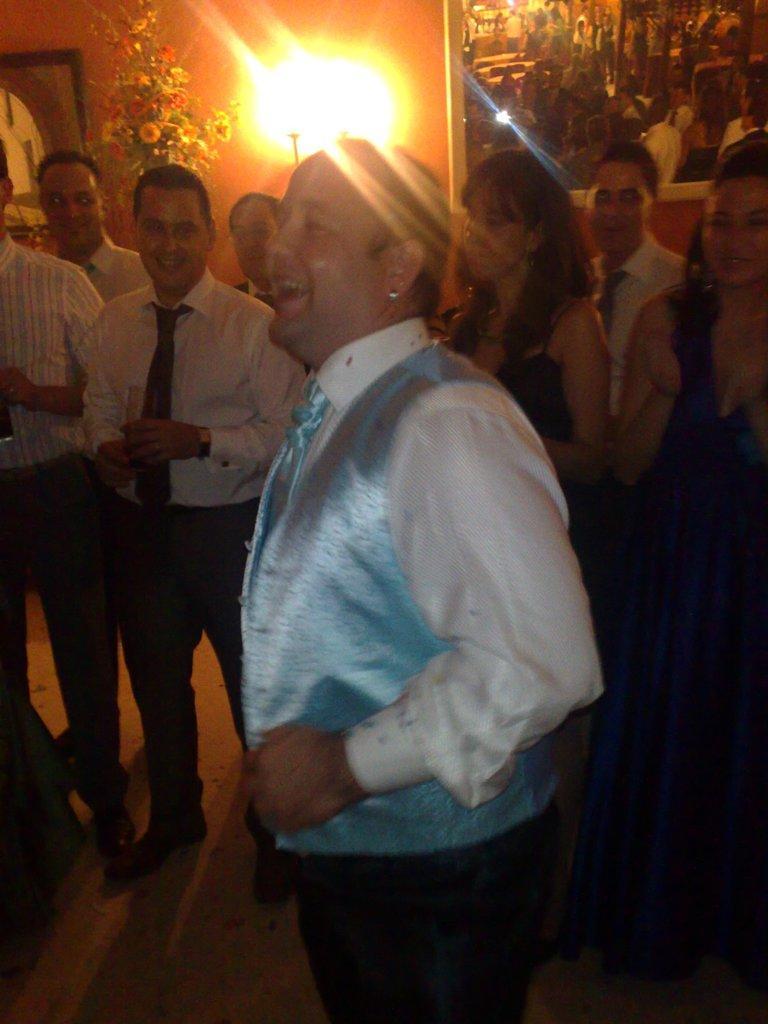Could you give a brief overview of what you see in this image? In this picture we can observe some persons. There are men and women in this picture. All of them are laughing. In the background we can observe yellow color light. There is a photo frame fixed to the wall. 